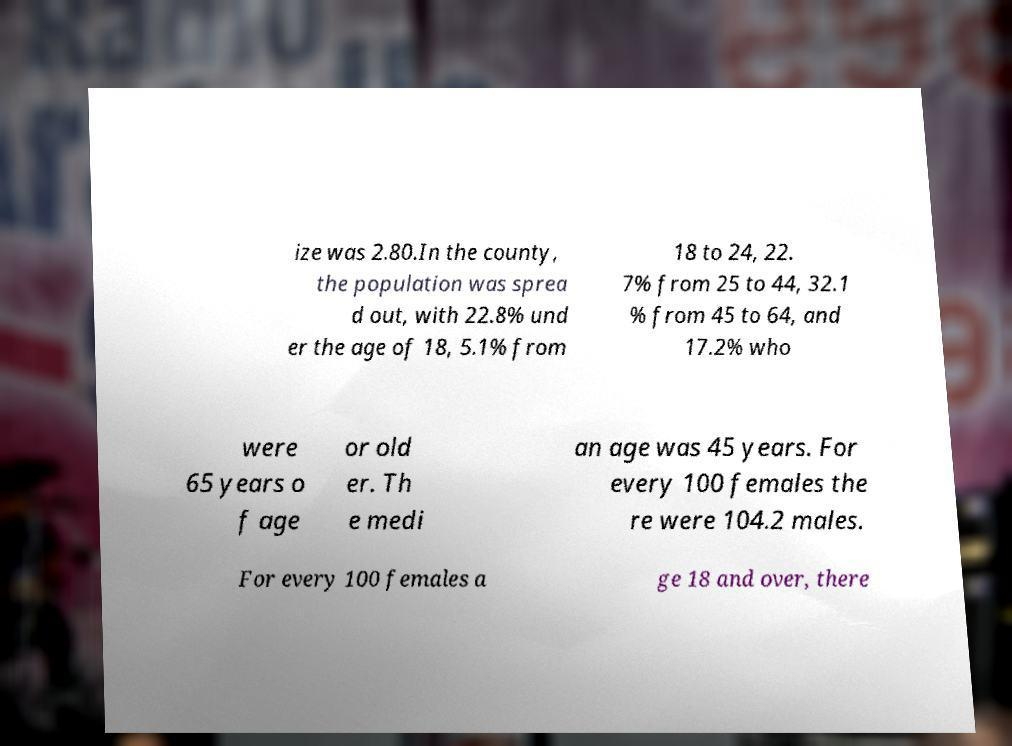I need the written content from this picture converted into text. Can you do that? ize was 2.80.In the county, the population was sprea d out, with 22.8% und er the age of 18, 5.1% from 18 to 24, 22. 7% from 25 to 44, 32.1 % from 45 to 64, and 17.2% who were 65 years o f age or old er. Th e medi an age was 45 years. For every 100 females the re were 104.2 males. For every 100 females a ge 18 and over, there 